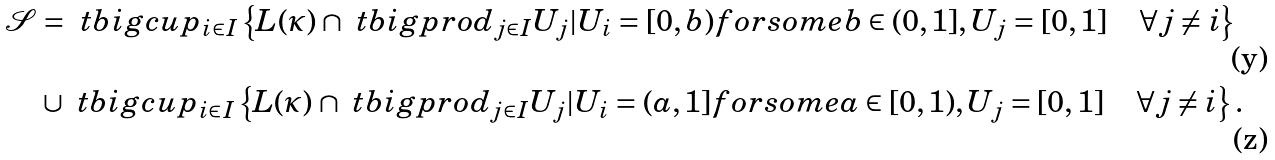Convert formula to latex. <formula><loc_0><loc_0><loc_500><loc_500>\mathcal { S } & = \ t b i g c u p _ { i \in I } \left \{ L ( \kappa ) \cap \ t b i g p r o d _ { j \in I } U _ { j } | U _ { i } = [ 0 , b ) f o r s o m e b \in ( 0 , 1 ] , U _ { j } = [ 0 , 1 ] \quad \forall j \ne i \right \} \\ & \cup \ t b i g c u p _ { i \in I } \left \{ L ( \kappa ) \cap \ t b i g p r o d _ { j \in I } U _ { j } | U _ { i } = ( a , 1 ] f o r s o m e a \in [ 0 , 1 ) , U _ { j } = [ 0 , 1 ] \quad \forall j \ne i \right \} .</formula> 